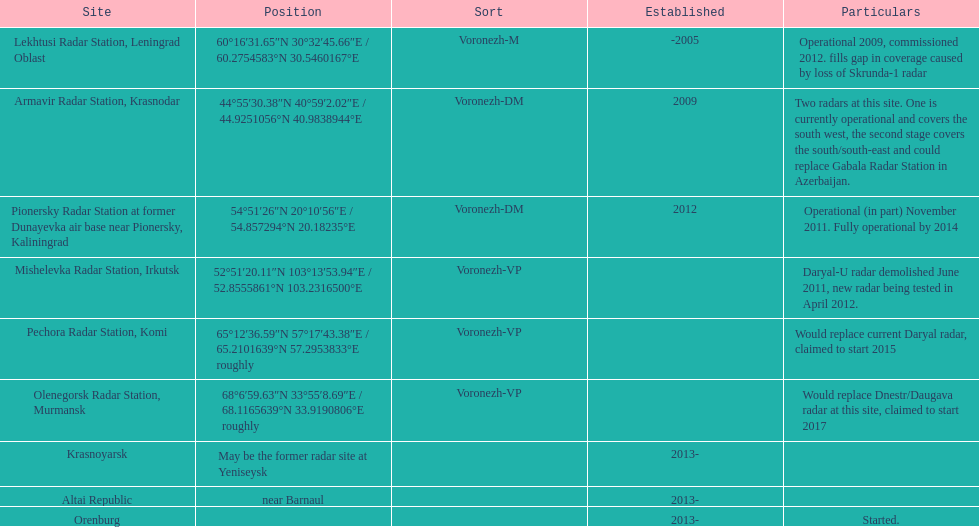Prior to 2010, what was the number of voronezh radars constructed? 2. 